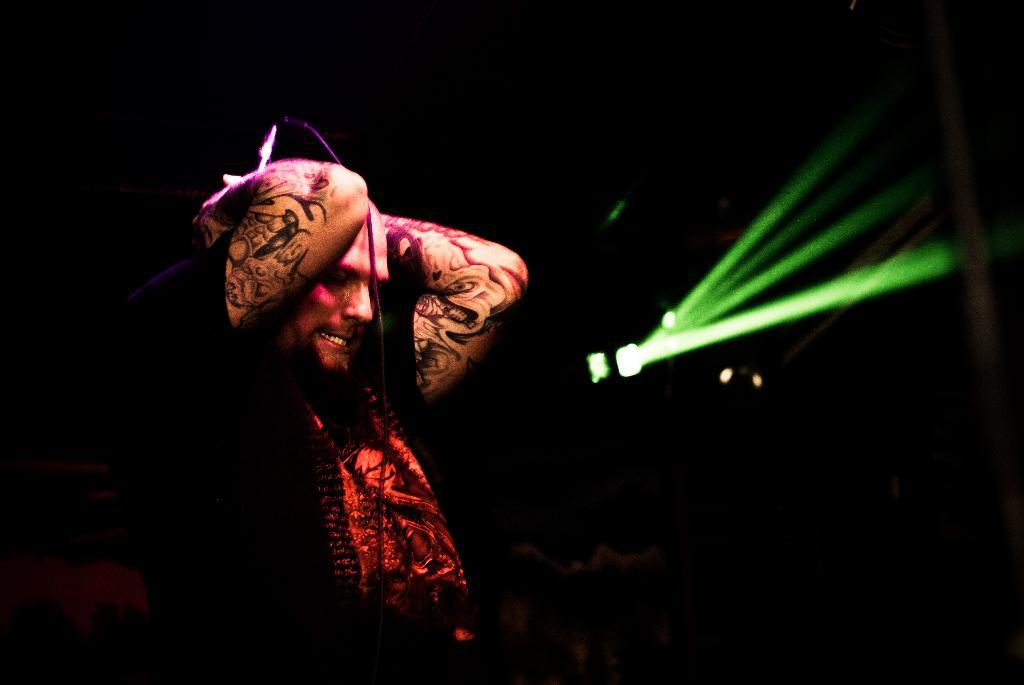Who is the main subject in the image? There is a man in the image. What is the man holding in the image? The man is holding a microphone. What can be seen on the right side of the image? There is a light on the right side of the image. How would you describe the overall lighting in the image? The background of the image is dark. What type of pan is being used to cook breakfast in the image? There is no pan or breakfast present in the image; it features a man holding a microphone. Can you see any yaks in the image? There are no yaks present in the image. 